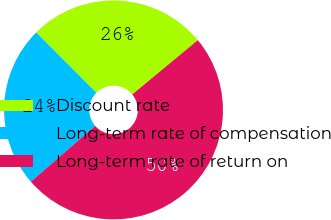<chart> <loc_0><loc_0><loc_500><loc_500><pie_chart><fcel>Discount rate<fcel>Long-term rate of compensation<fcel>Long-term rate of return on<nl><fcel>26.47%<fcel>23.9%<fcel>49.63%<nl></chart> 